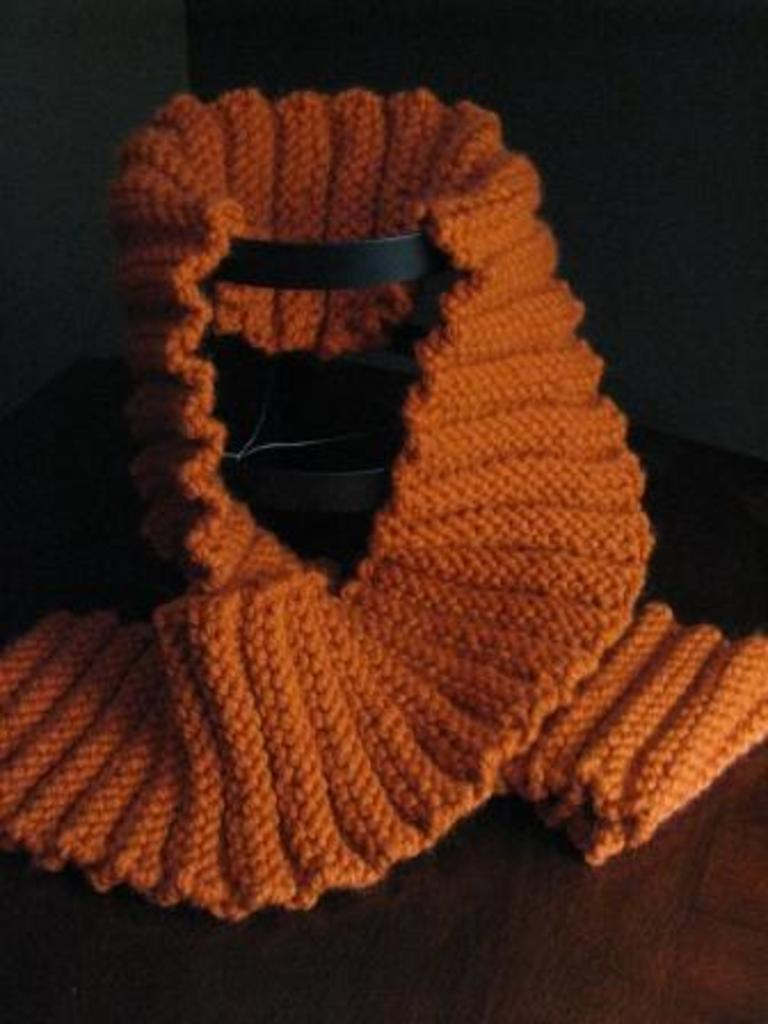What type of clothing item is in the image? There is a woolen scarf in the image. What color is the scarf? The scarf is orange in color. How is the scarf displayed in the image? The scarf is placed on a black stand. Can you see any mountains in the image? There are no mountains present in the image; it features a woolen scarf on a black stand. Is there a zebra wearing the orange scarf in the image? There is no zebra present in the image, and the scarf is not being worn by any animal. 